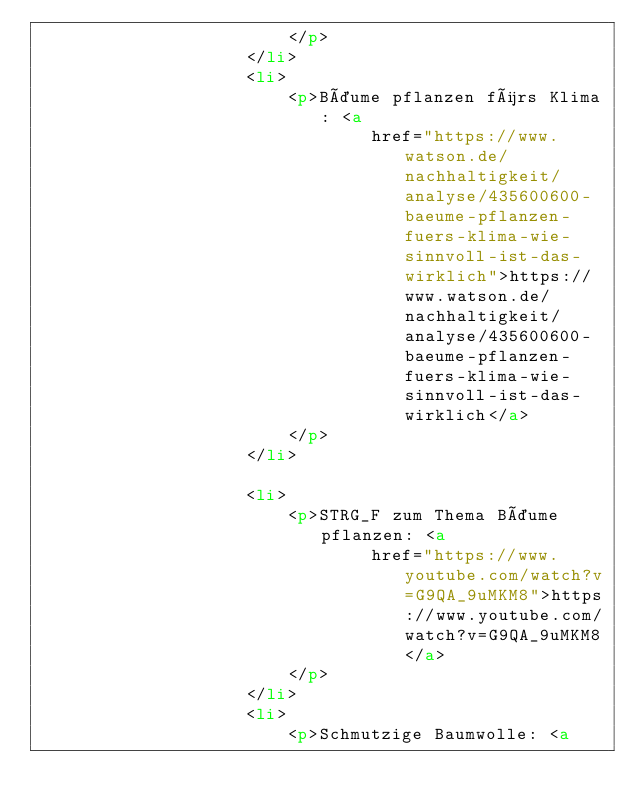Convert code to text. <code><loc_0><loc_0><loc_500><loc_500><_HTML_>                        </p>
                    </li>
                    <li>
                        <p>Bäume pflanzen fürs Klima: <a
                                href="https://www.watson.de/nachhaltigkeit/analyse/435600600-baeume-pflanzen-fuers-klima-wie-sinnvoll-ist-das-wirklich">https://www.watson.de/nachhaltigkeit/analyse/435600600-baeume-pflanzen-fuers-klima-wie-sinnvoll-ist-das-wirklich</a>
                        </p>
                    </li>

                    <li>
                        <p>STRG_F zum Thema Bäume pflanzen: <a
                                href="https://www.youtube.com/watch?v=G9QA_9uMKM8">https://www.youtube.com/watch?v=G9QA_9uMKM8</a>
                        </p>
                    </li>
                    <li>
                        <p>Schmutzige Baumwolle: <a</code> 